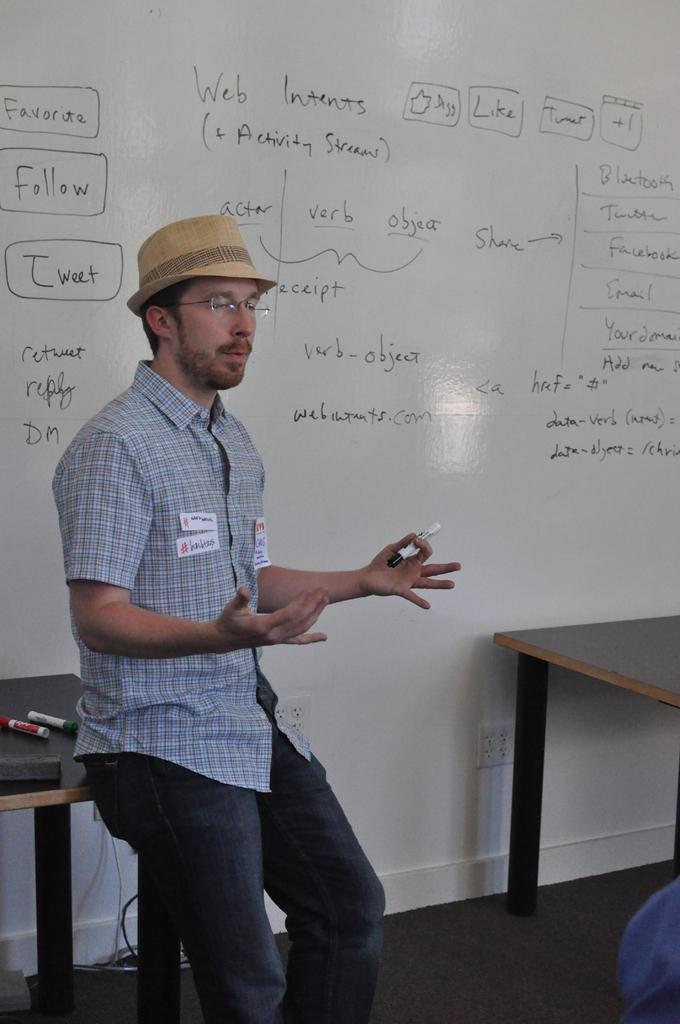<image>
Describe the image concisely. A man wearing a blue shirt is in front of a large whiteboard that has boxed word "tweet" near his head. 